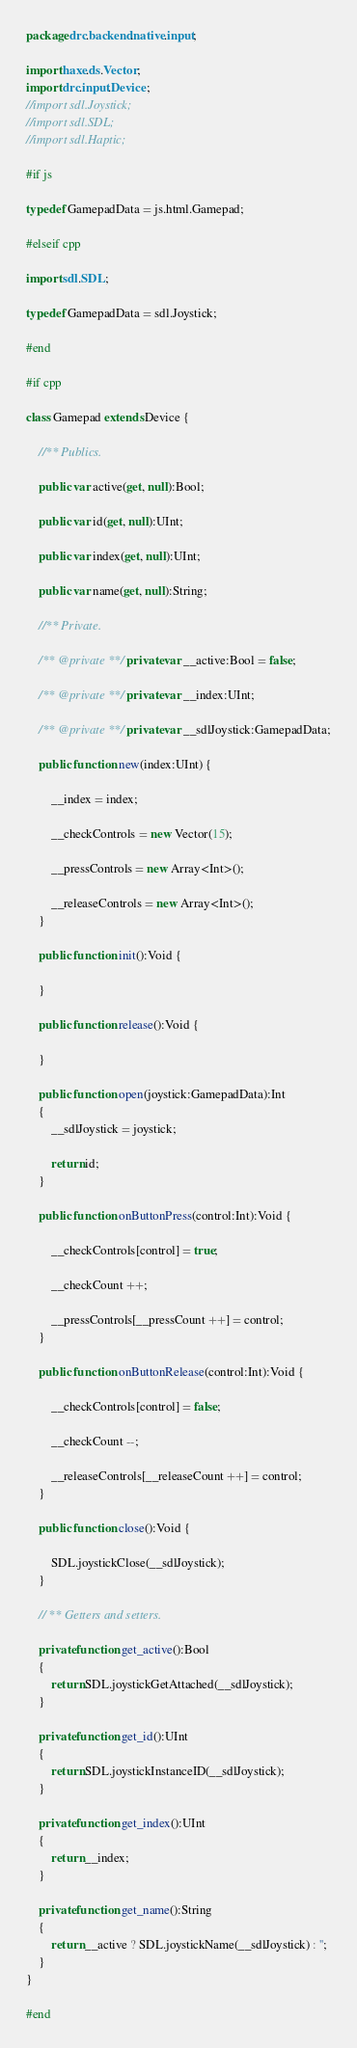Convert code to text. <code><loc_0><loc_0><loc_500><loc_500><_Haxe_>package drc.backend.native.input;

import haxe.ds.Vector;
import drc.input.Device;
//import sdl.Joystick;
//import sdl.SDL;
//import sdl.Haptic;

#if js

typedef GamepadData = js.html.Gamepad;

#elseif cpp

import sdl.SDL;

typedef GamepadData = sdl.Joystick;

#end

#if cpp

class Gamepad extends Device {
	
	//** Publics.
	
	public var active(get, null):Bool;
	
	public var id(get, null):UInt;
	
	public var index(get, null):UInt;
	
	public var name(get, null):String;
	
	//** Private.
	
	/** @private **/ private var __active:Bool = false;
	
	/** @private **/ private var __index:UInt;
	
	/** @private **/ private var __sdlJoystick:GamepadData;
	
	public function new(index:UInt) {

		__index = index;
		
		__checkControls = new Vector(15);
		
		__pressControls = new Array<Int>();
		
		__releaseControls = new Array<Int>();
	}
	
	public function init():Void {
		
	}
	
	public function release():Void {
		
	}
	
	public function open(joystick:GamepadData):Int
	{
		__sdlJoystick = joystick;
		
		return id;
	}
	
	public function onButtonPress(control:Int):Void {

		__checkControls[control] = true;
		
		__checkCount ++;
		
		__pressControls[__pressCount ++] = control;
	}
	
	public function onButtonRelease(control:Int):Void {

		__checkControls[control] = false;
		
		__checkCount --;
		
		__releaseControls[__releaseCount ++] = control;
	}
	
	public function close():Void {
		
		SDL.joystickClose(__sdlJoystick);
	}
	
	// ** Getters and setters.
	
	private function get_active():Bool
	{
		return SDL.joystickGetAttached(__sdlJoystick);
	}
	
	private function get_id():UInt
	{
		return SDL.joystickInstanceID(__sdlJoystick);
	}

	private function get_index():UInt
	{
		return __index;
	}
	
	private function get_name():String
	{
		return __active ? SDL.joystickName(__sdlJoystick) : '';
	}
}

#end</code> 